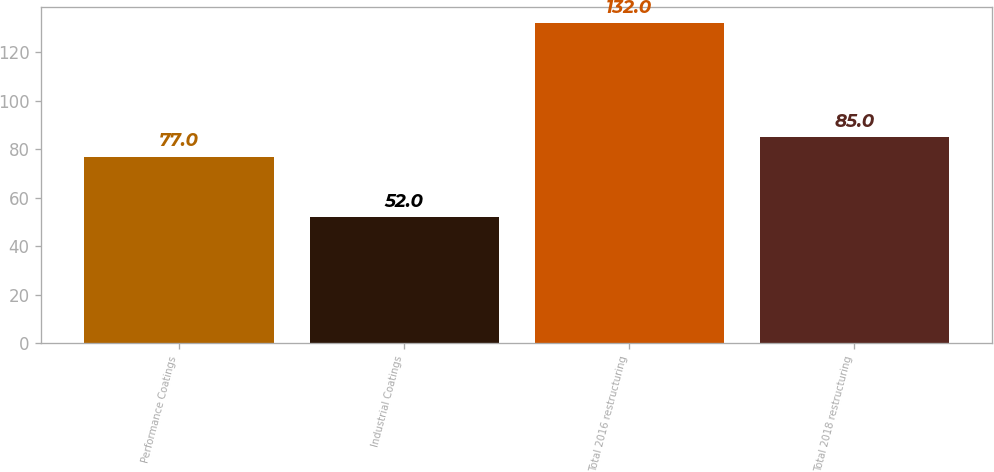Convert chart. <chart><loc_0><loc_0><loc_500><loc_500><bar_chart><fcel>Performance Coatings<fcel>Industrial Coatings<fcel>Total 2016 restructuring<fcel>Total 2018 restructuring<nl><fcel>77<fcel>52<fcel>132<fcel>85<nl></chart> 